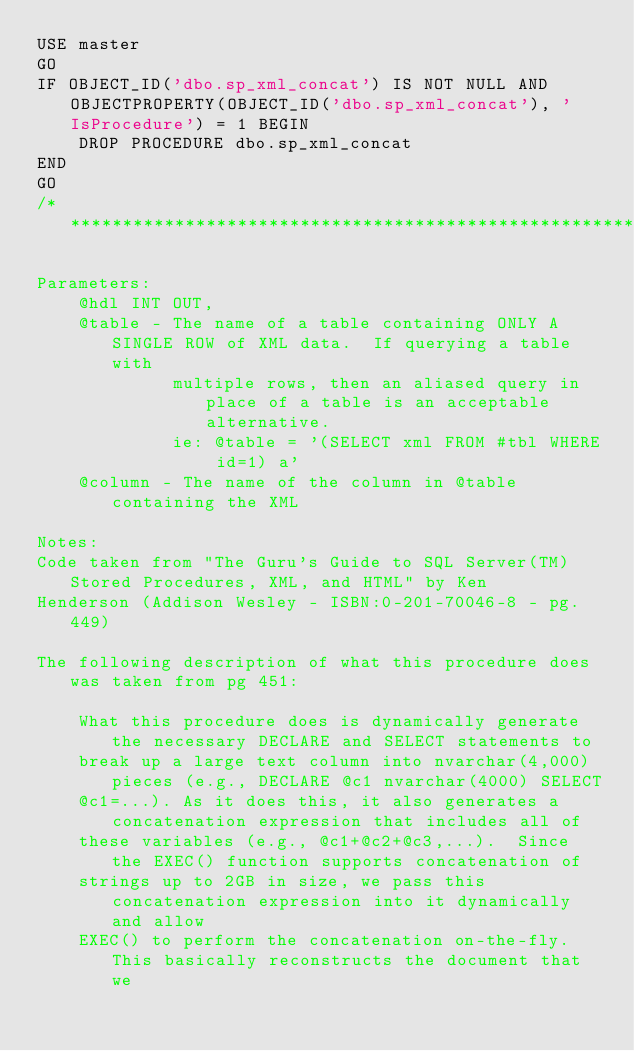<code> <loc_0><loc_0><loc_500><loc_500><_SQL_>USE master
GO
IF OBJECT_ID('dbo.sp_xml_concat') IS NOT NULL AND OBJECTPROPERTY(OBJECT_ID('dbo.sp_xml_concat'), 'IsProcedure') = 1 BEGIN
    DROP PROCEDURE dbo.sp_xml_concat
END
GO
/***************************************************************************************************

Parameters:
    @hdl INT OUT,
    @table - The name of a table containing ONLY A SINGLE ROW of XML data.  If querying a table with
             multiple rows, then an aliased query in place of a table is an acceptable alternative.
             ie: @table = '(SELECT xml FROM #tbl WHERE id=1) a'
    @column - The name of the column in @table containing the XML

Notes:
Code taken from "The Guru's Guide to SQL Server(TM) Stored Procedures, XML, and HTML" by Ken
Henderson (Addison Wesley - ISBN:0-201-70046-8 - pg. 449)

The following description of what this procedure does was taken from pg 451:

    What this procedure does is dynamically generate the necessary DECLARE and SELECT statements to
    break up a large text column into nvarchar(4,000) pieces (e.g., DECLARE @c1 nvarchar(4000) SELECT
    @c1=...). As it does this, it also generates a concatenation expression that includes all of
    these variables (e.g., @c1+@c2+@c3,...).  Since the EXEC() function supports concatenation of
    strings up to 2GB in size, we pass this concatenation expression into it dynamically and allow
    EXEC() to perform the concatenation on-the-fly.  This basically reconstructs the document that we</code> 